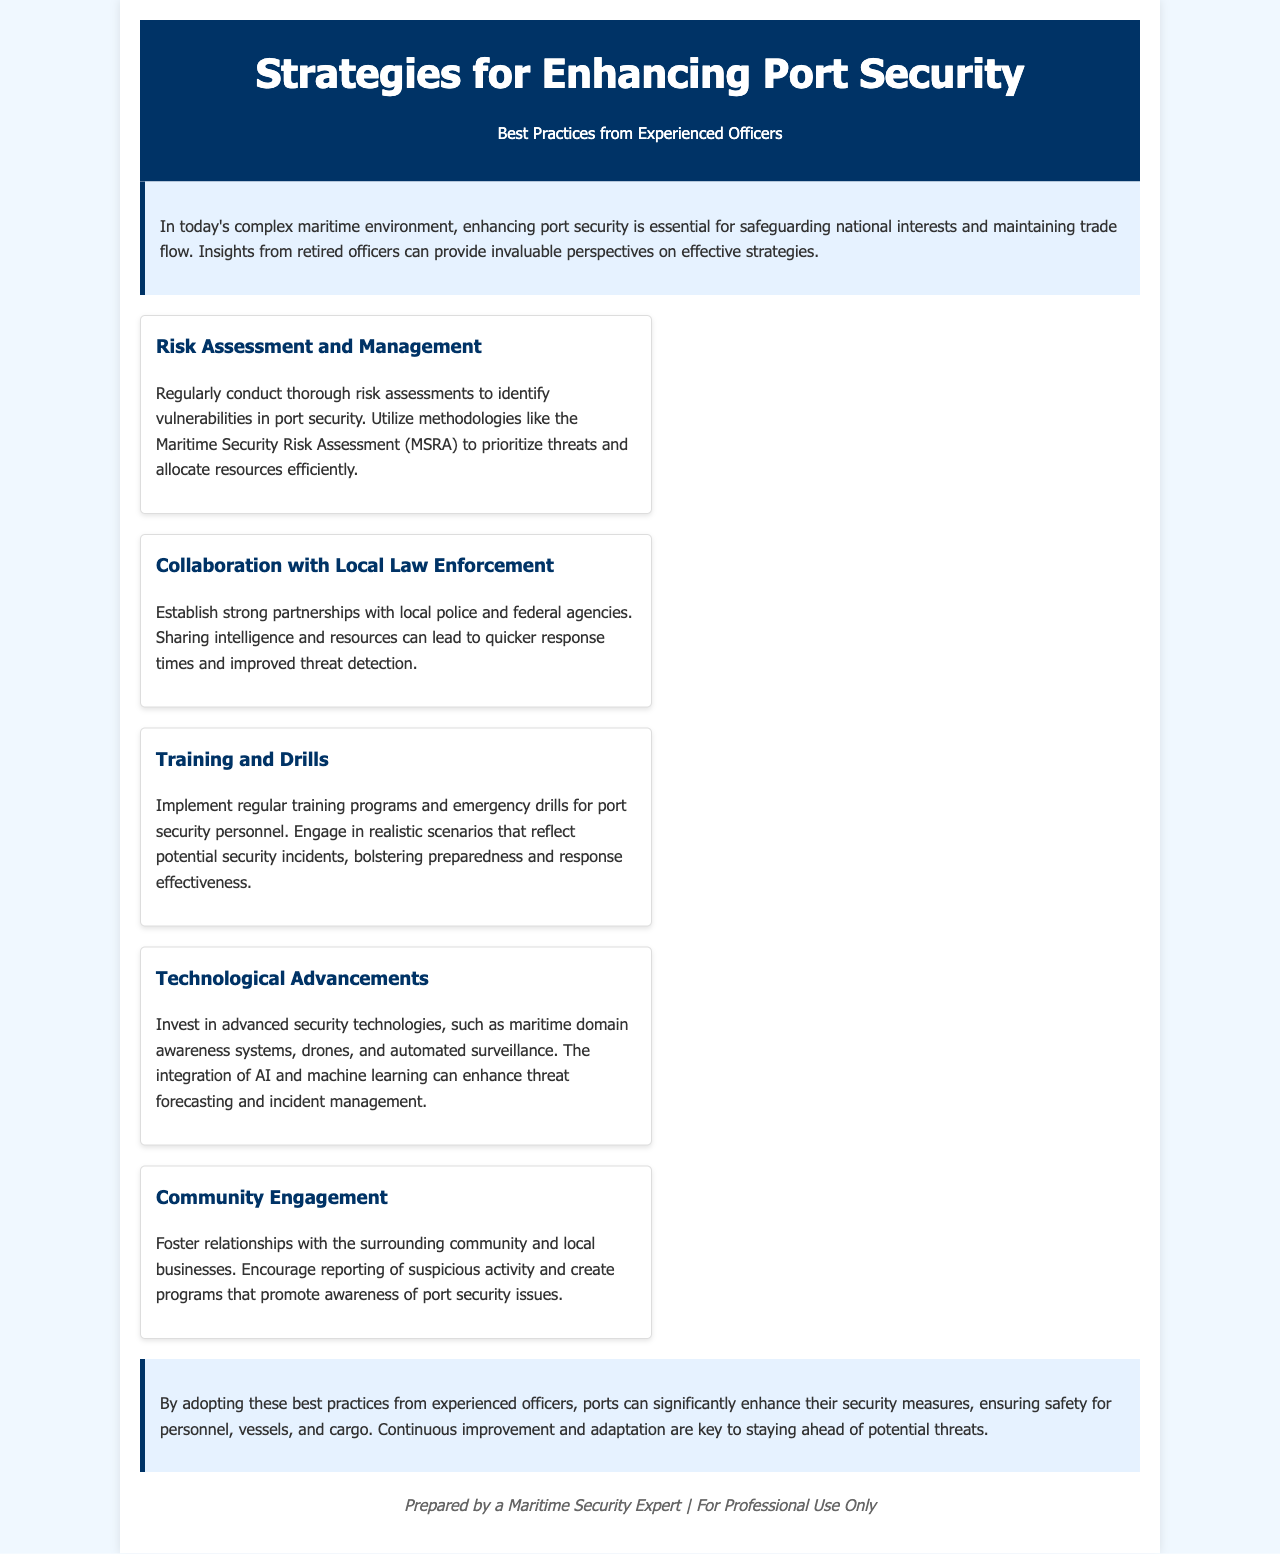what is the title of the brochure? The title of the brochure is found in the header section, summarizing the overall theme.
Answer: Strategies for Enhancing Port Security who is the target audience for this brochure? The intended audience is indicated by the preparation line in the footer, which specifies a professional context.
Answer: Maritime Security Expert how many best practices are listed in the brochure? The total number of practices can be counted from the 'best practices' section.
Answer: Five what is one method mentioned for risk assessment? The brochure specifies a particular methodology for assessments in the security field.
Answer: Maritime Security Risk Assessment (MSRA) what is the color of the header section? The color of the header section conveys the visual identity of the document.
Answer: #003366 what is one aspect of community engagement highlighted? The brochure notes the significance of fostering community relationships as a part of security strategy.
Answer: Reporting of suspicious activity why is collaboration with local law enforcement important? The reasoning is provided in the text describing how relationships can enhance responses to security situations.
Answer: Quicker response times what type of technologies are recommended for investment? The document explicitly suggests advanced technologies for enhancing maritime security not just generally, but through specific examples.
Answer: Maritime domain awareness systems how should training programs be characterized according to the brochure? The document describes the training programs using specific action verbs to indicate their nature and intent.
Answer: Regular 